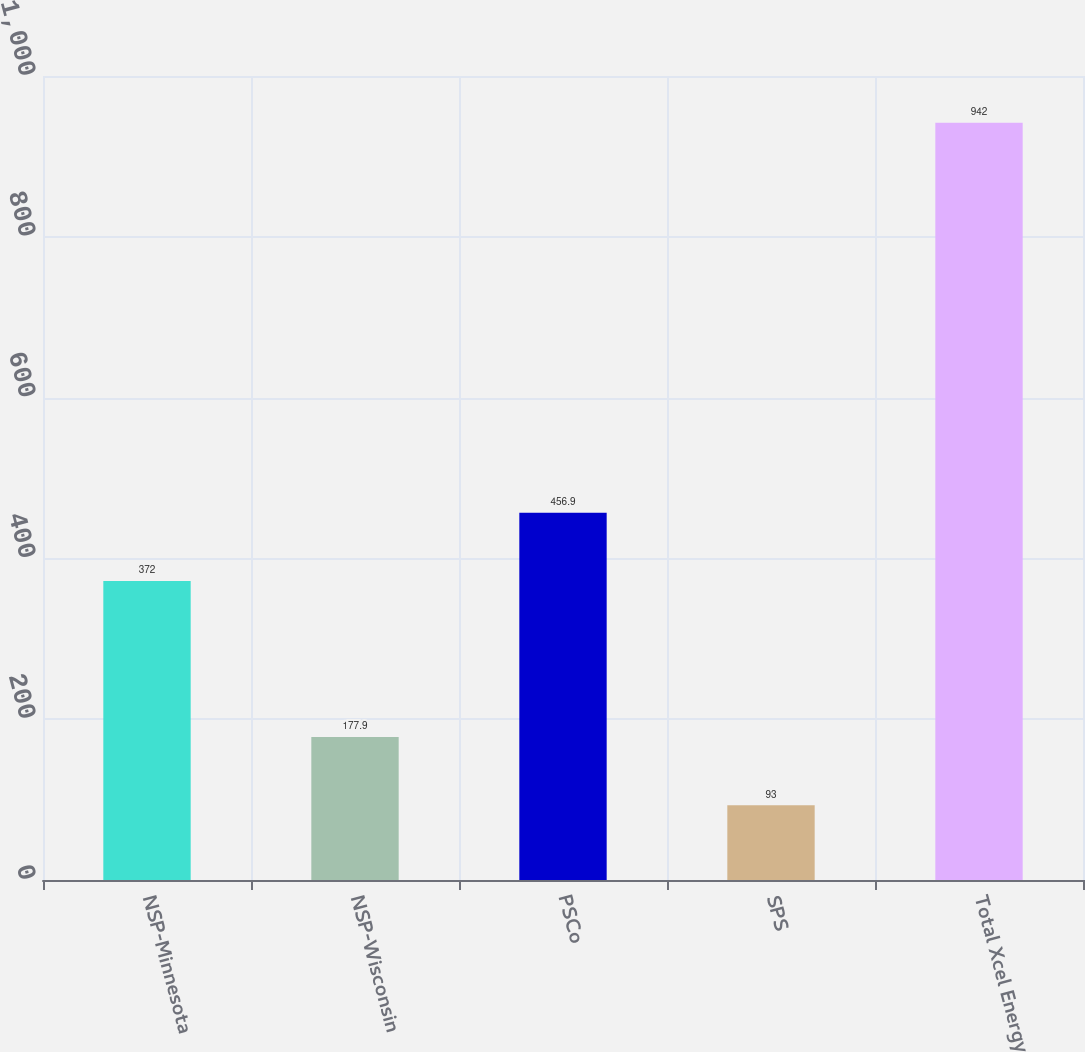<chart> <loc_0><loc_0><loc_500><loc_500><bar_chart><fcel>NSP-Minnesota<fcel>NSP-Wisconsin<fcel>PSCo<fcel>SPS<fcel>Total Xcel Energy<nl><fcel>372<fcel>177.9<fcel>456.9<fcel>93<fcel>942<nl></chart> 